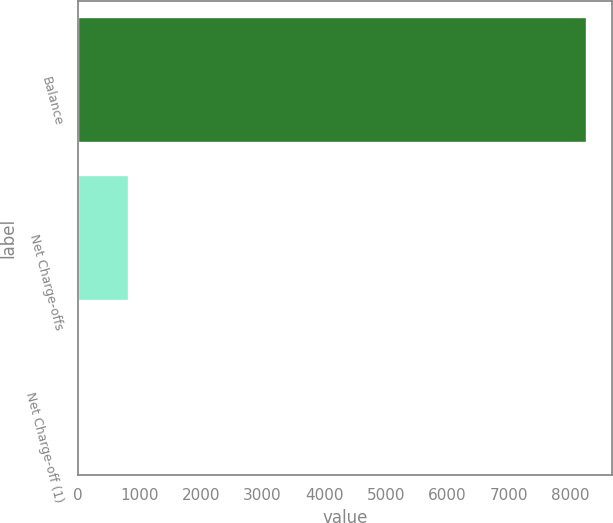Convert chart to OTSL. <chart><loc_0><loc_0><loc_500><loc_500><bar_chart><fcel>Balance<fcel>Net Charge-offs<fcel>Net Charge-off (1)<nl><fcel>8262<fcel>827.32<fcel>1.24<nl></chart> 